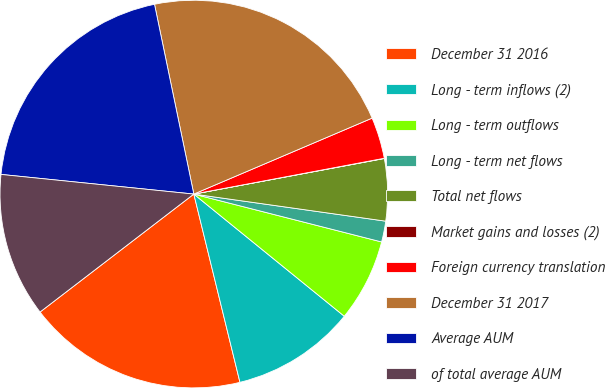Convert chart to OTSL. <chart><loc_0><loc_0><loc_500><loc_500><pie_chart><fcel>December 31 2016<fcel>Long - term inflows (2)<fcel>Long - term outflows<fcel>Long - term net flows<fcel>Total net flows<fcel>Market gains and losses (2)<fcel>Foreign currency translation<fcel>December 31 2017<fcel>Average AUM<fcel>of total average AUM<nl><fcel>18.41%<fcel>10.32%<fcel>6.88%<fcel>1.74%<fcel>5.17%<fcel>0.02%<fcel>3.45%<fcel>21.84%<fcel>20.13%<fcel>12.03%<nl></chart> 